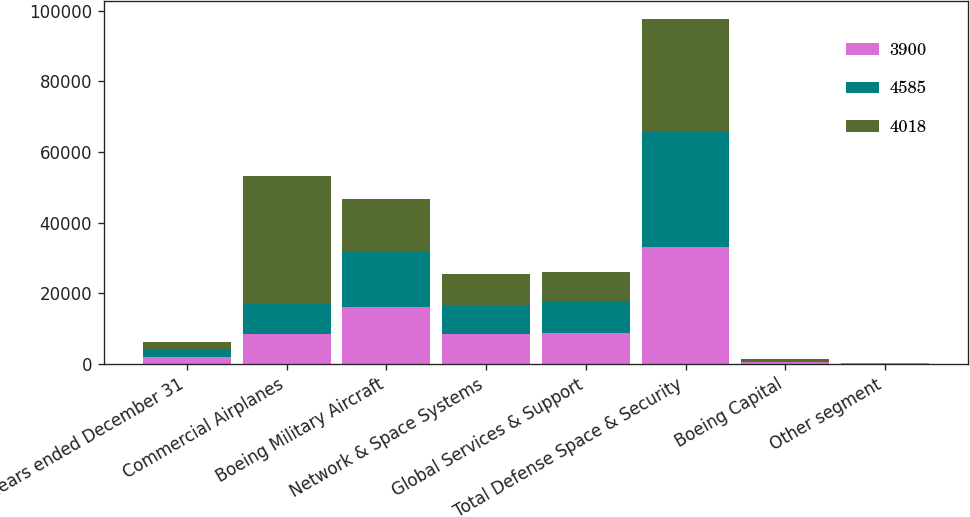<chart> <loc_0><loc_0><loc_500><loc_500><stacked_bar_chart><ecel><fcel>Years ended December 31<fcel>Commercial Airplanes<fcel>Boeing Military Aircraft<fcel>Network & Space Systems<fcel>Global Services & Support<fcel>Total Defense Space & Security<fcel>Boeing Capital<fcel>Other segment<nl><fcel>3900<fcel>2013<fcel>8469.5<fcel>15936<fcel>8512<fcel>8749<fcel>33197<fcel>408<fcel>102<nl><fcel>4585<fcel>2012<fcel>8469.5<fcel>16019<fcel>7911<fcel>8677<fcel>32607<fcel>468<fcel>106<nl><fcel>4018<fcel>2011<fcel>36171<fcel>14585<fcel>8964<fcel>8427<fcel>31976<fcel>547<fcel>123<nl></chart> 